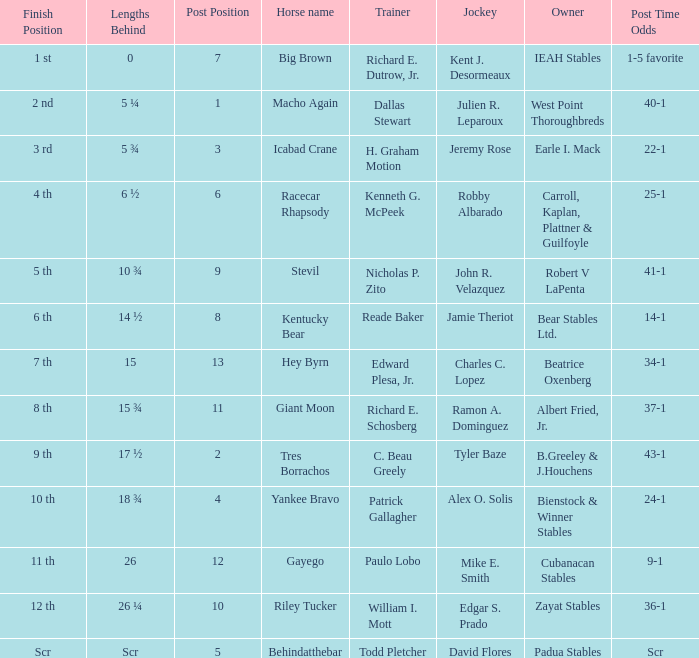Who was the rider with starting odds of 34-1? Charles C. Lopez. 